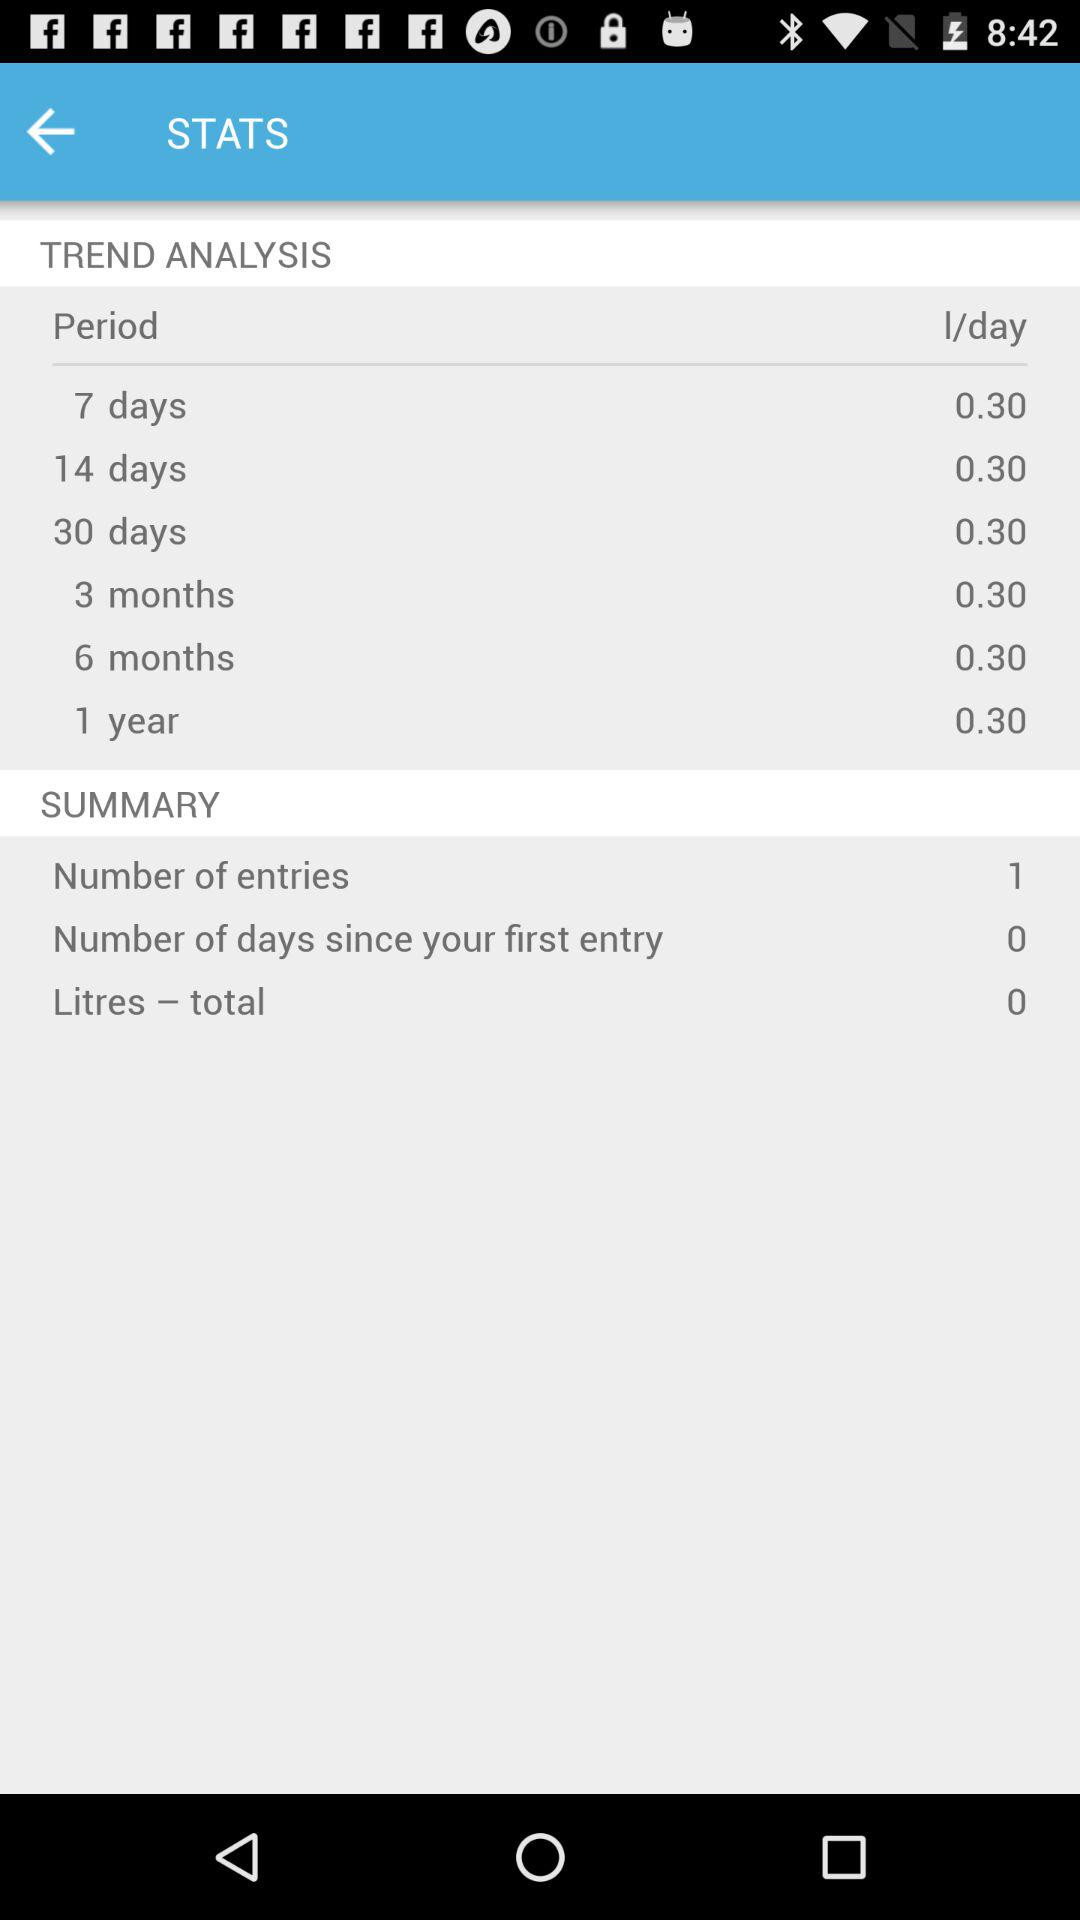What is the I/day value for a period of 6 months? The I/day value for a period of 6 months is 0.30. 